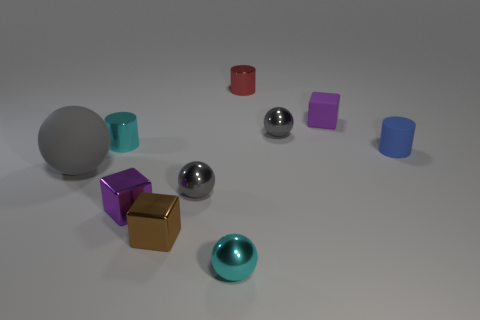Is there anything else that is the same size as the gray matte sphere?
Your answer should be very brief. No. Is the tiny blue thing the same shape as the tiny red metallic object?
Ensure brevity in your answer.  Yes. There is a cyan thing that is the same shape as the blue thing; what is its size?
Offer a very short reply. Small. How many small purple things have the same material as the tiny cyan cylinder?
Offer a terse response. 1. What number of objects are purple metallic balls or cubes?
Offer a very short reply. 3. There is a cube that is left of the tiny brown block; is there a thing that is to the right of it?
Your answer should be compact. Yes. Are there more tiny gray things that are behind the large sphere than small gray objects that are in front of the tiny brown object?
Your answer should be compact. Yes. What material is the tiny thing that is the same color as the matte block?
Provide a succinct answer. Metal. What number of rubber balls are the same color as the big thing?
Make the answer very short. 0. Is the color of the ball behind the small rubber cylinder the same as the rubber thing that is on the left side of the small cyan cylinder?
Give a very brief answer. Yes. 